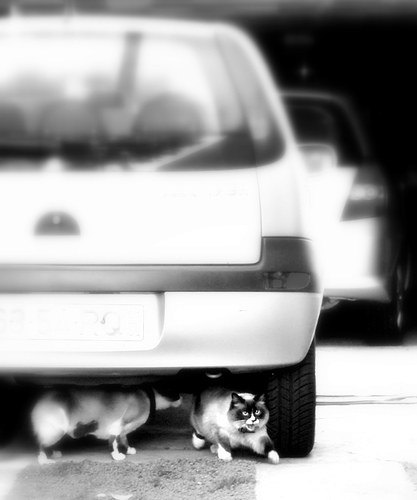Is there anything unique about the setting where the cats are found? The image shows a typical urban setting with cars parked, suggesting these cats may be strays or outdoor pets in a city environment. Do the cats seem to be aware of the photographer? The cat with distinct markings is looking directly at the camera, indicating it is aware of the photographer's presence. 